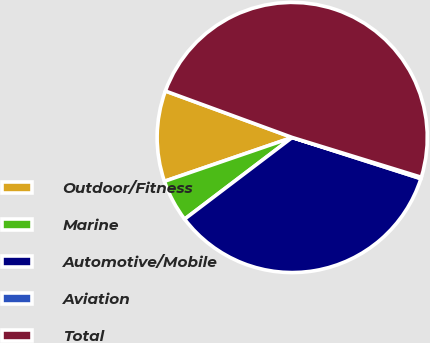<chart> <loc_0><loc_0><loc_500><loc_500><pie_chart><fcel>Outdoor/Fitness<fcel>Marine<fcel>Automotive/Mobile<fcel>Aviation<fcel>Total<nl><fcel>10.85%<fcel>5.07%<fcel>34.74%<fcel>0.17%<fcel>49.17%<nl></chart> 